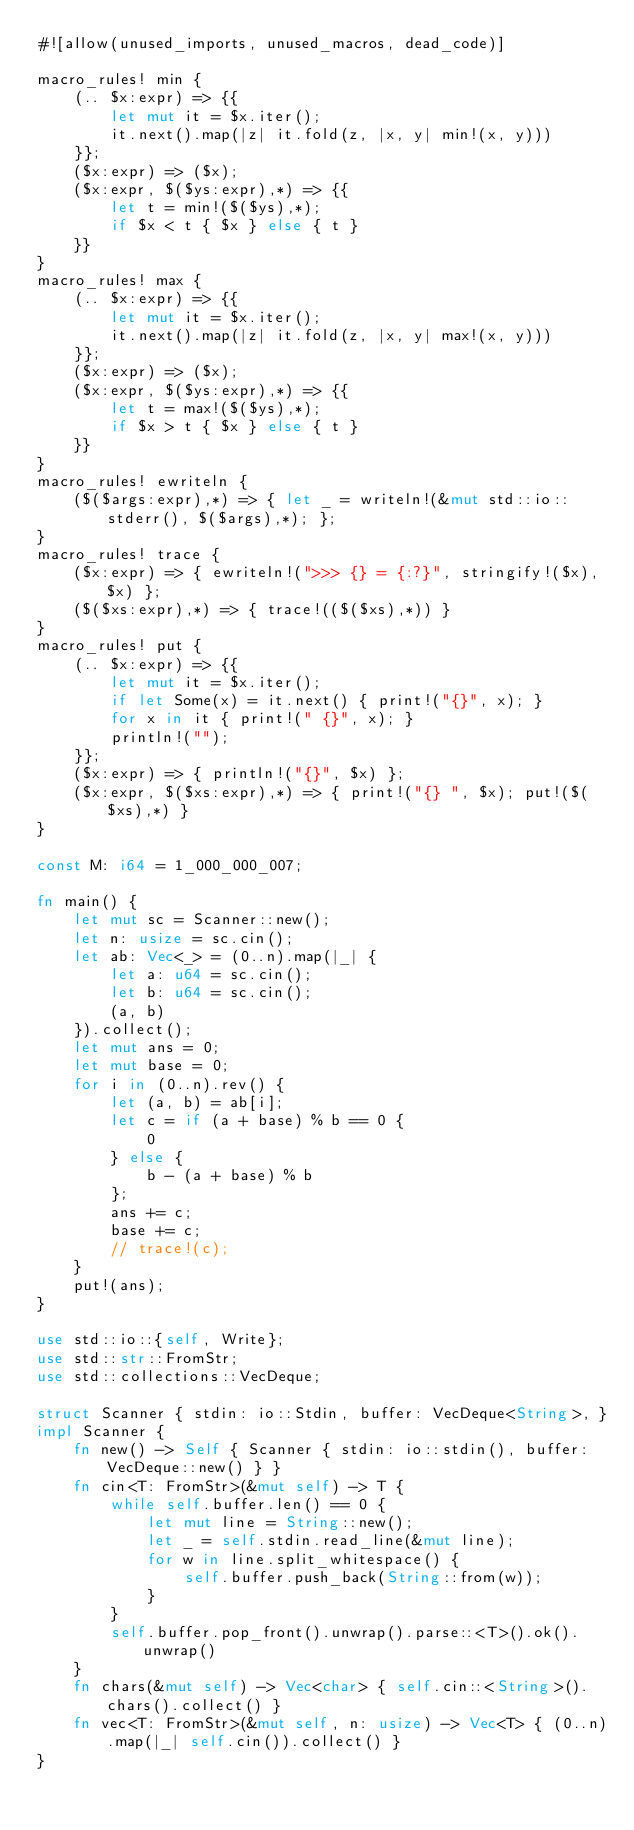<code> <loc_0><loc_0><loc_500><loc_500><_Rust_>#![allow(unused_imports, unused_macros, dead_code)]

macro_rules! min {
    (.. $x:expr) => {{
        let mut it = $x.iter();
        it.next().map(|z| it.fold(z, |x, y| min!(x, y)))
    }};
    ($x:expr) => ($x);
    ($x:expr, $($ys:expr),*) => {{
        let t = min!($($ys),*);
        if $x < t { $x } else { t }
    }}
}
macro_rules! max {
    (.. $x:expr) => {{
        let mut it = $x.iter();
        it.next().map(|z| it.fold(z, |x, y| max!(x, y)))
    }};
    ($x:expr) => ($x);
    ($x:expr, $($ys:expr),*) => {{
        let t = max!($($ys),*);
        if $x > t { $x } else { t }
    }}
}
macro_rules! ewriteln {
    ($($args:expr),*) => { let _ = writeln!(&mut std::io::stderr(), $($args),*); };
}
macro_rules! trace {
    ($x:expr) => { ewriteln!(">>> {} = {:?}", stringify!($x), $x) };
    ($($xs:expr),*) => { trace!(($($xs),*)) }
}
macro_rules! put {
    (.. $x:expr) => {{
        let mut it = $x.iter();
        if let Some(x) = it.next() { print!("{}", x); }
        for x in it { print!(" {}", x); }
        println!("");
    }};
    ($x:expr) => { println!("{}", $x) };
    ($x:expr, $($xs:expr),*) => { print!("{} ", $x); put!($($xs),*) }
}

const M: i64 = 1_000_000_007;

fn main() {
    let mut sc = Scanner::new();
    let n: usize = sc.cin();
    let ab: Vec<_> = (0..n).map(|_| {
        let a: u64 = sc.cin();
        let b: u64 = sc.cin();
        (a, b)
    }).collect();
    let mut ans = 0;
    let mut base = 0;
    for i in (0..n).rev() {
        let (a, b) = ab[i];
        let c = if (a + base) % b == 0 {
            0
        } else {
            b - (a + base) % b
        };
        ans += c;
        base += c;
        // trace!(c);
    }
    put!(ans);
}

use std::io::{self, Write};
use std::str::FromStr;
use std::collections::VecDeque;

struct Scanner { stdin: io::Stdin, buffer: VecDeque<String>, }
impl Scanner {
    fn new() -> Self { Scanner { stdin: io::stdin(), buffer: VecDeque::new() } }
    fn cin<T: FromStr>(&mut self) -> T {
        while self.buffer.len() == 0 {
            let mut line = String::new();
            let _ = self.stdin.read_line(&mut line);
            for w in line.split_whitespace() {
                self.buffer.push_back(String::from(w));
            }
        }
        self.buffer.pop_front().unwrap().parse::<T>().ok().unwrap()
    }
    fn chars(&mut self) -> Vec<char> { self.cin::<String>().chars().collect() }
    fn vec<T: FromStr>(&mut self, n: usize) -> Vec<T> { (0..n).map(|_| self.cin()).collect() }
}
</code> 